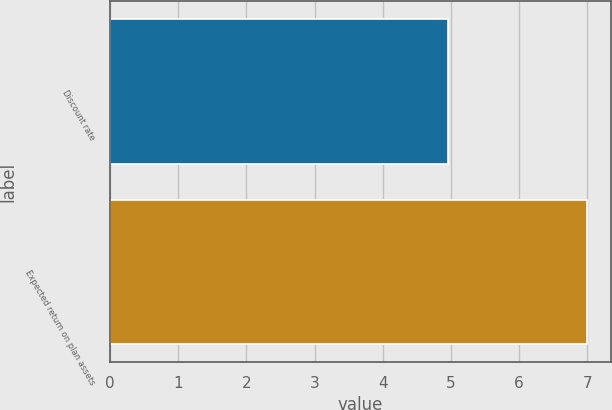Convert chart to OTSL. <chart><loc_0><loc_0><loc_500><loc_500><bar_chart><fcel>Discount rate<fcel>Expected return on plan assets<nl><fcel>4.95<fcel>7<nl></chart> 